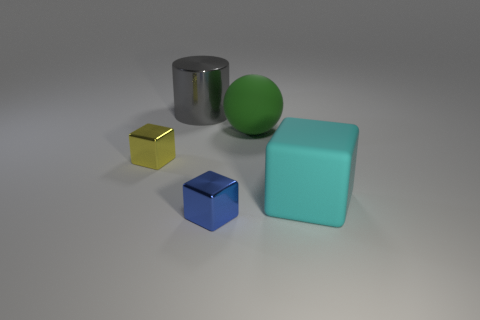Add 4 big gray shiny objects. How many objects exist? 9 Subtract all balls. How many objects are left? 4 Add 5 green matte objects. How many green matte objects exist? 6 Subtract 1 cyan cubes. How many objects are left? 4 Subtract all small cyan metallic things. Subtract all large matte cubes. How many objects are left? 4 Add 4 big gray objects. How many big gray objects are left? 5 